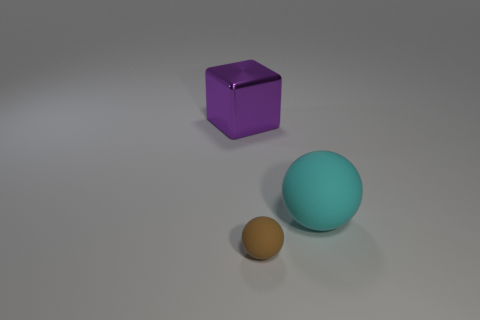Are there fewer tiny matte things that are behind the large cyan ball than brown objects?
Give a very brief answer. Yes. What number of balls are the same size as the block?
Offer a terse response. 1. There is a thing that is behind the cyan rubber object; what shape is it?
Your response must be concise. Cube. Are there fewer small matte balls than cyan matte cylinders?
Offer a terse response. No. There is a thing behind the cyan rubber ball; what is its size?
Provide a short and direct response. Large. Are there more large balls than things?
Your answer should be compact. No. What is the material of the cyan ball?
Your response must be concise. Rubber. What number of other objects are there of the same material as the large purple cube?
Provide a short and direct response. 0. What number of big cyan balls are there?
Ensure brevity in your answer.  1. There is a big cyan object that is the same shape as the small brown rubber object; what is it made of?
Offer a very short reply. Rubber. 